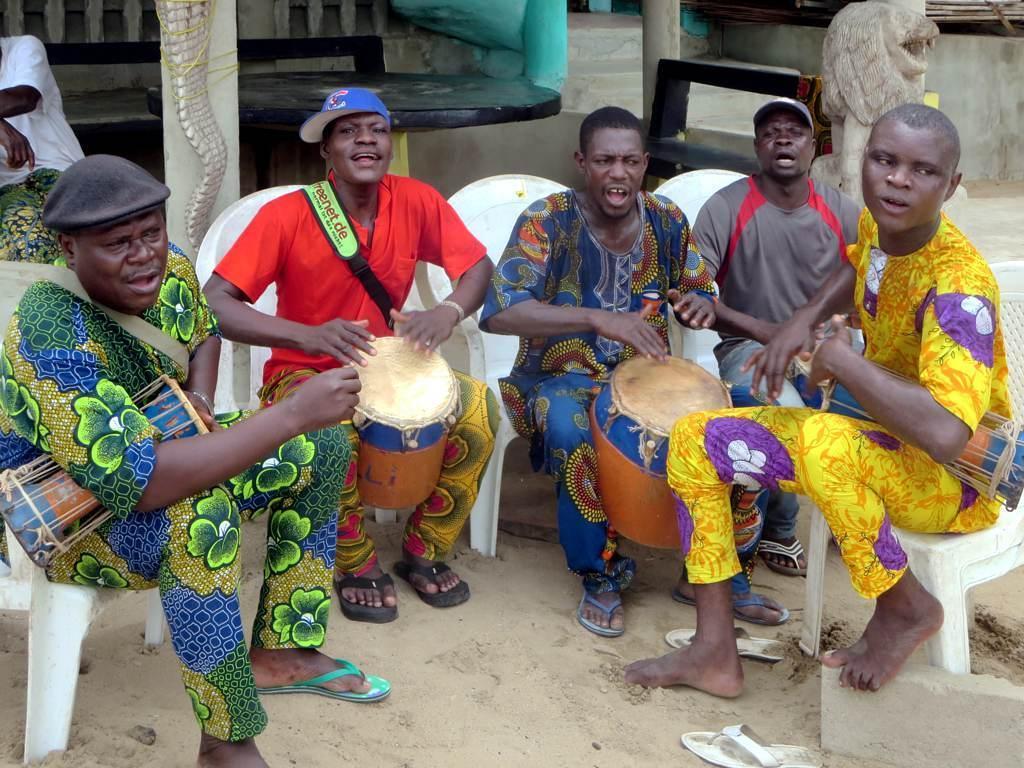Can you describe this image briefly? There are people sitting on chairs and playing drums and we can see sand. In the background we can see statues, pillars, table, person and wall. 